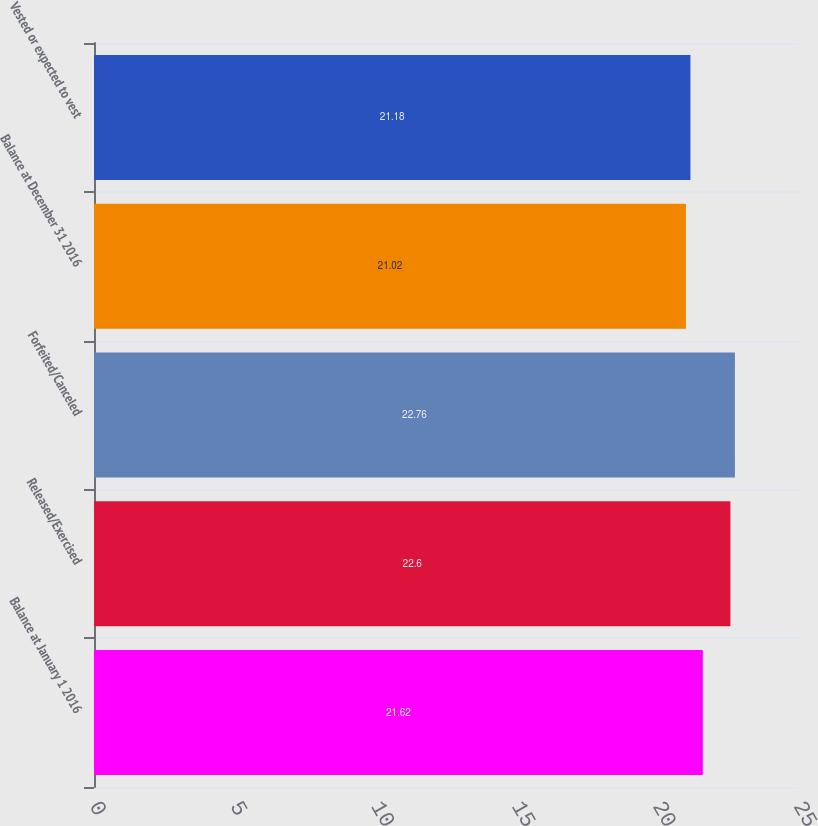Convert chart. <chart><loc_0><loc_0><loc_500><loc_500><bar_chart><fcel>Balance at January 1 2016<fcel>Released/Exercised<fcel>Forfeited/Canceled<fcel>Balance at December 31 2016<fcel>Vested or expected to vest<nl><fcel>21.62<fcel>22.6<fcel>22.76<fcel>21.02<fcel>21.18<nl></chart> 